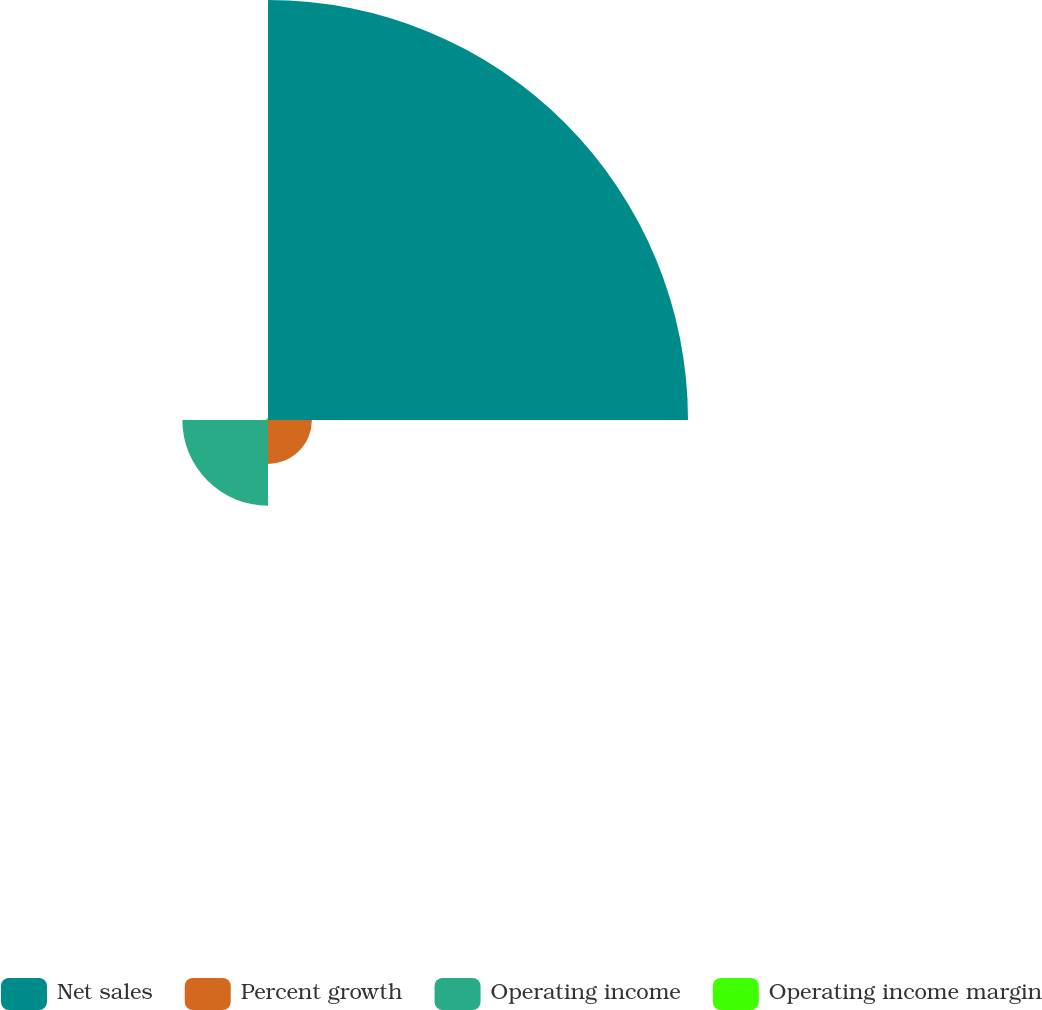Convert chart to OTSL. <chart><loc_0><loc_0><loc_500><loc_500><pie_chart><fcel>Net sales<fcel>Percent growth<fcel>Operating income<fcel>Operating income margin<nl><fcel>76.13%<fcel>7.96%<fcel>15.53%<fcel>0.38%<nl></chart> 